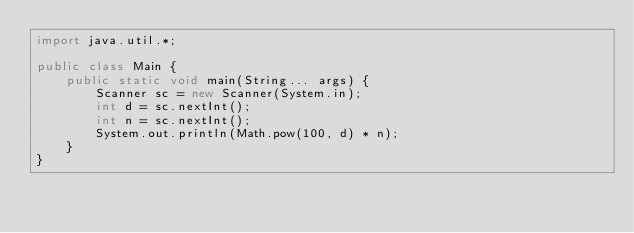Convert code to text. <code><loc_0><loc_0><loc_500><loc_500><_Java_>import java.util.*;

public class Main {
	public static void main(String... args) {
		Scanner sc = new Scanner(System.in);
		int d = sc.nextInt();
		int n = sc.nextInt();
		System.out.println(Math.pow(100, d) * n);
	}
}
</code> 